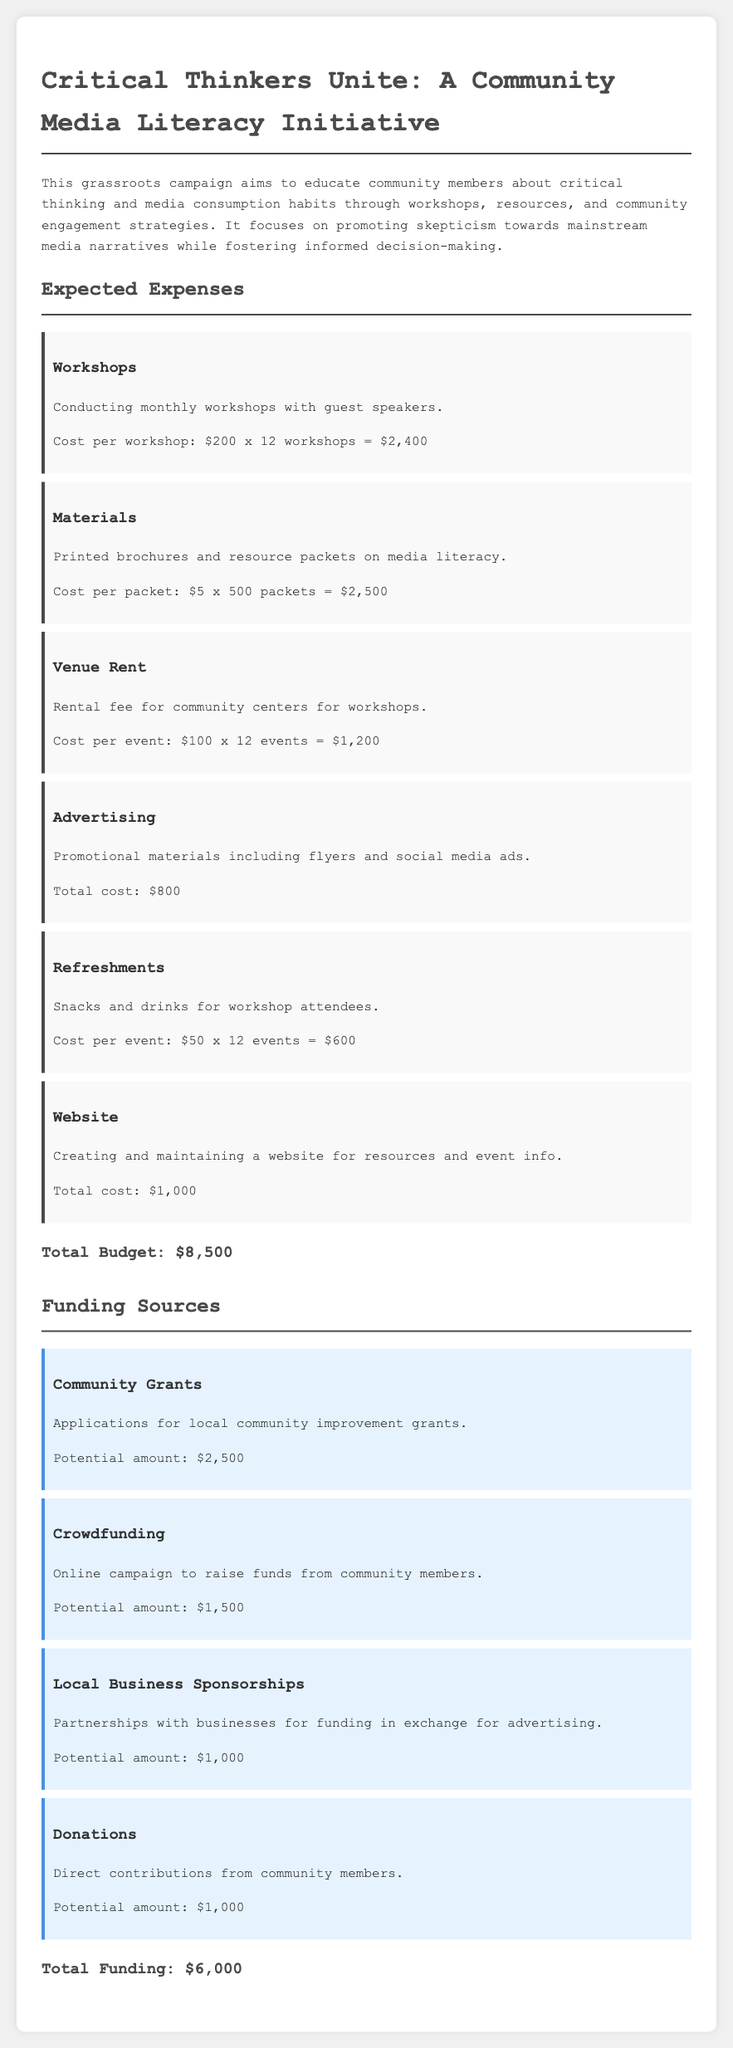What is the main goal of the campaign? The main goal of the campaign is to educate community members about critical thinking and media consumption habits.
Answer: Educate community members about critical thinking and media consumption habits How much is allocated for workshops? The total cost calculated for conducting monthly workshops is $200 per workshop for 12 workshops, which amounts to $2,400.
Answer: $2,400 What is the expected total budget for the campaign? The total budget is provided in the document as the sum of all expected expenses, which totals $8,500.
Answer: $8,500 How many printed packets are planned for distribution? The document states that 500 packets of printed brochures and resource materials are planned for distribution.
Answer: 500 packets What is the potential funding amount from local business sponsorships? The expected funding amount from local business sponsorships is detailed in the document as $1,000.
Answer: $1,000 What are the main methods of funding mentioned in the document? The document lists community grants, crowdfunding, local business sponsorships, and donations as the main methods of funding.
Answer: Community grants, crowdfunding, local business sponsorships, donations How much is allocated for advertising? The document specifies that the total cost for promotional materials, which includes advertising, is $800.
Answer: $800 What is the cost for refreshments per event? The cost for providing snacks and drinks for attendees is given as $50 per event across 12 events, totaling $600.
Answer: $50 per event What type of materials will be printed for the initiative? The document specifies that printed brochures and resource packets on media literacy will be produced for the initiative.
Answer: Printed brochures and resource packets on media literacy 